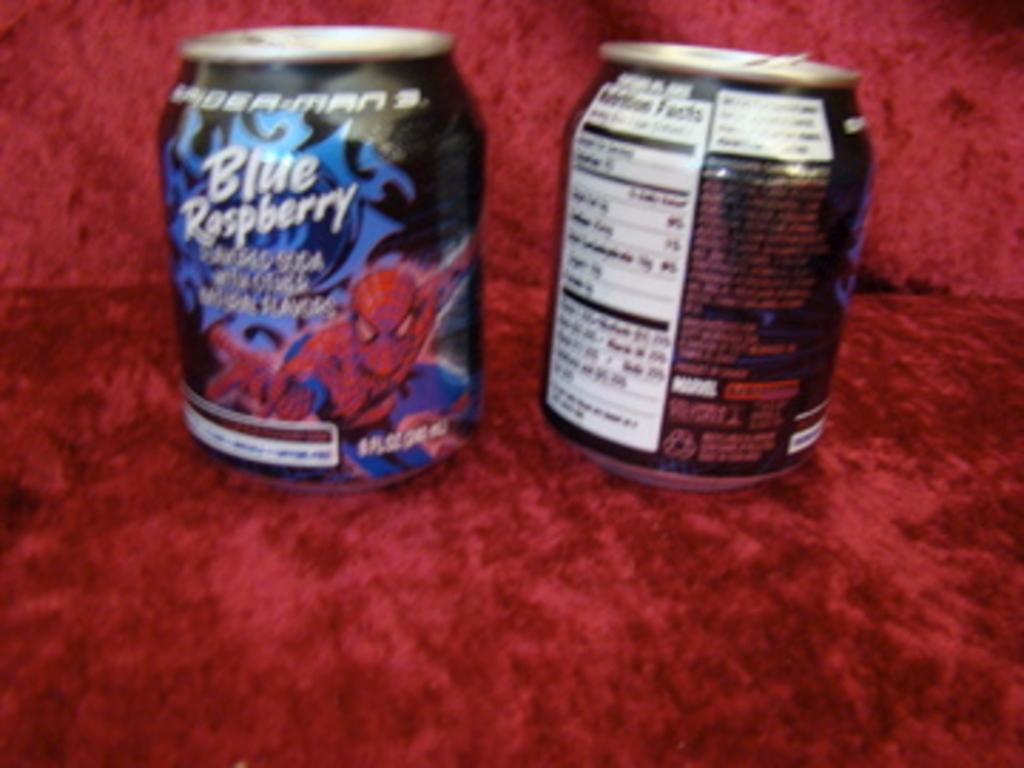<image>
Give a short and clear explanation of the subsequent image. The front and back view of small can of Blue Raspberry Spider Man soda. 